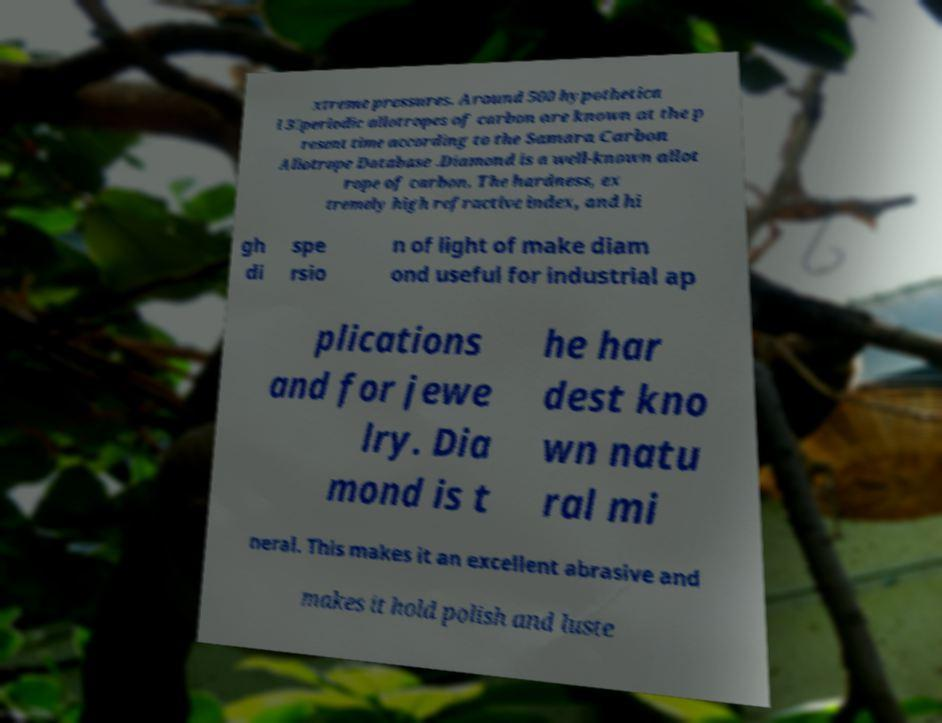What messages or text are displayed in this image? I need them in a readable, typed format. xtreme pressures. Around 500 hypothetica l 3‑periodic allotropes of carbon are known at the p resent time according to the Samara Carbon Allotrope Database .Diamond is a well-known allot rope of carbon. The hardness, ex tremely high refractive index, and hi gh di spe rsio n of light of make diam ond useful for industrial ap plications and for jewe lry. Dia mond is t he har dest kno wn natu ral mi neral. This makes it an excellent abrasive and makes it hold polish and luste 